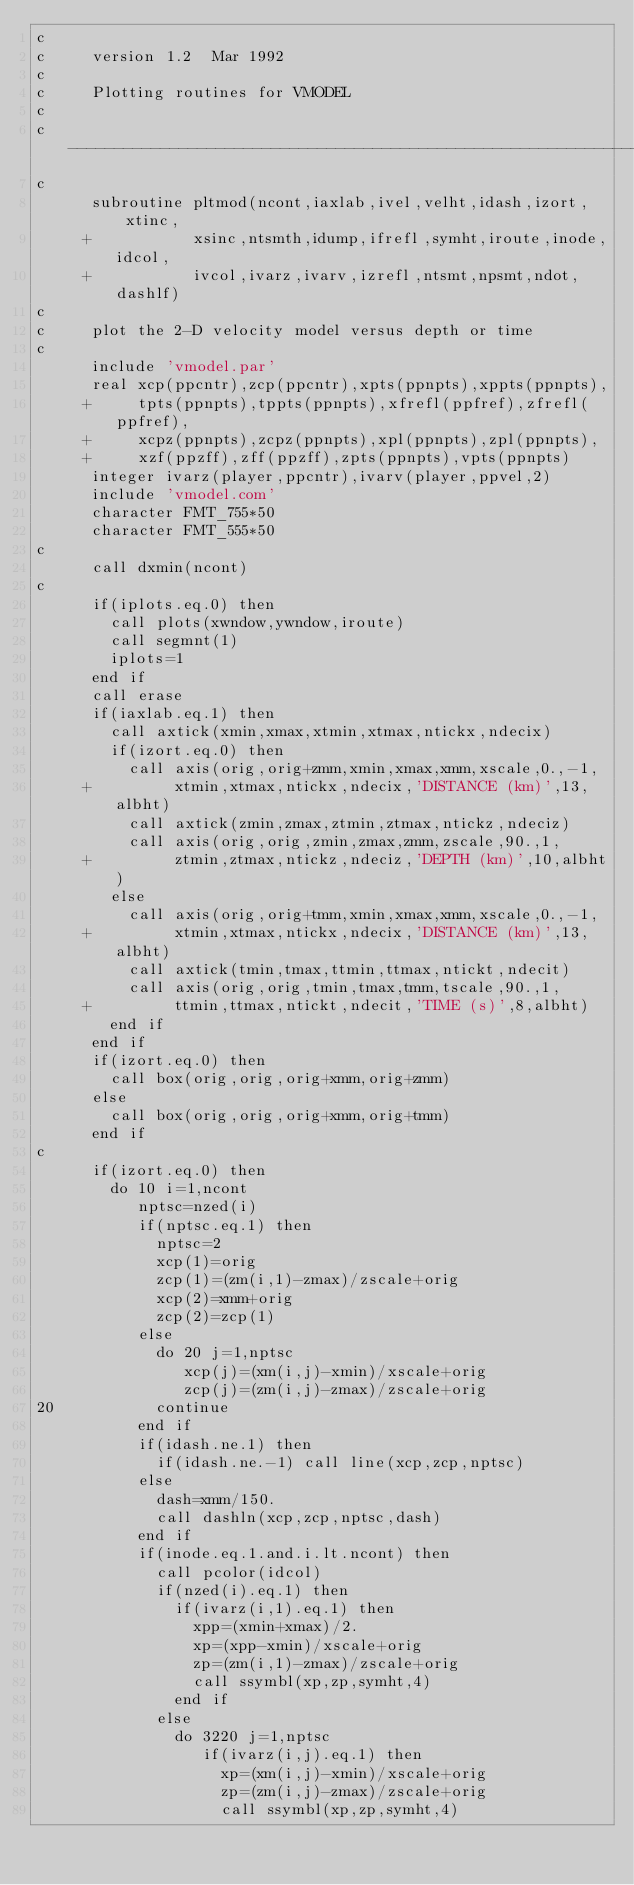<code> <loc_0><loc_0><loc_500><loc_500><_FORTRAN_>c
c     version 1.2  Mar 1992
c
c     Plotting routines for VMODEL
c
c     ----------------------------------------------------------------
c
      subroutine pltmod(ncont,iaxlab,ivel,velht,idash,izort,xtinc,
     +           xsinc,ntsmth,idump,ifrefl,symht,iroute,inode,idcol,
     +           ivcol,ivarz,ivarv,izrefl,ntsmt,npsmt,ndot,dashlf)
c
c     plot the 2-D velocity model versus depth or time
c
      include 'vmodel.par'
      real xcp(ppcntr),zcp(ppcntr),xpts(ppnpts),xppts(ppnpts),
     +     tpts(ppnpts),tppts(ppnpts),xfrefl(ppfref),zfrefl(ppfref),
     +     xcpz(ppnpts),zcpz(ppnpts),xpl(ppnpts),zpl(ppnpts),
     +     xzf(ppzff),zff(ppzff),zpts(ppnpts),vpts(ppnpts)
      integer ivarz(player,ppcntr),ivarv(player,ppvel,2)
      include 'vmodel.com'
      character FMT_755*50
      character FMT_555*50
c
      call dxmin(ncont)
c
      if(iplots.eq.0) then
        call plots(xwndow,ywndow,iroute)
        call segmnt(1)
        iplots=1
      end if
      call erase
      if(iaxlab.eq.1) then
        call axtick(xmin,xmax,xtmin,xtmax,ntickx,ndecix)
        if(izort.eq.0) then
          call axis(orig,orig+zmm,xmin,xmax,xmm,xscale,0.,-1,
     +         xtmin,xtmax,ntickx,ndecix,'DISTANCE (km)',13,albht)
          call axtick(zmin,zmax,ztmin,ztmax,ntickz,ndeciz)
          call axis(orig,orig,zmin,zmax,zmm,zscale,90.,1,
     +         ztmin,ztmax,ntickz,ndeciz,'DEPTH (km)',10,albht)
        else
          call axis(orig,orig+tmm,xmin,xmax,xmm,xscale,0.,-1,
     +         xtmin,xtmax,ntickx,ndecix,'DISTANCE (km)',13,albht)
          call axtick(tmin,tmax,ttmin,ttmax,ntickt,ndecit)
          call axis(orig,orig,tmin,tmax,tmm,tscale,90.,1,
     +         ttmin,ttmax,ntickt,ndecit,'TIME (s)',8,albht)
        end if
      end if
      if(izort.eq.0) then
        call box(orig,orig,orig+xmm,orig+zmm)
      else
        call box(orig,orig,orig+xmm,orig+tmm)
      end if
c
      if(izort.eq.0) then
        do 10 i=1,ncont
           nptsc=nzed(i)
           if(nptsc.eq.1) then
             nptsc=2
             xcp(1)=orig
             zcp(1)=(zm(i,1)-zmax)/zscale+orig
             xcp(2)=xmm+orig
             zcp(2)=zcp(1)
           else
             do 20 j=1,nptsc
                xcp(j)=(xm(i,j)-xmin)/xscale+orig
                zcp(j)=(zm(i,j)-zmax)/zscale+orig
20           continue
           end if
           if(idash.ne.1) then
             if(idash.ne.-1) call line(xcp,zcp,nptsc)
           else
             dash=xmm/150.
             call dashln(xcp,zcp,nptsc,dash)
           end if
           if(inode.eq.1.and.i.lt.ncont) then
             call pcolor(idcol)
             if(nzed(i).eq.1) then
               if(ivarz(i,1).eq.1) then
                 xpp=(xmin+xmax)/2.
                 xp=(xpp-xmin)/xscale+orig
                 zp=(zm(i,1)-zmax)/zscale+orig
                 call ssymbl(xp,zp,symht,4)
               end if
             else
               do 3220 j=1,nptsc
                  if(ivarz(i,j).eq.1) then
                    xp=(xm(i,j)-xmin)/xscale+orig
                    zp=(zm(i,j)-zmax)/zscale+orig
                    call ssymbl(xp,zp,symht,4)</code> 